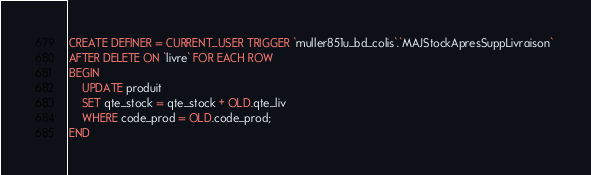Convert code to text. <code><loc_0><loc_0><loc_500><loc_500><_SQL_>CREATE DEFINER = CURRENT_USER TRIGGER `muller851u_bd_colis`.`MAJStockApresSuppLivraison` 
AFTER DELETE ON `livre` FOR EACH ROW
BEGIN
	UPDATE produit
	SET qte_stock = qte_stock + OLD.qte_liv
	WHERE code_prod = OLD.code_prod;
END</code> 